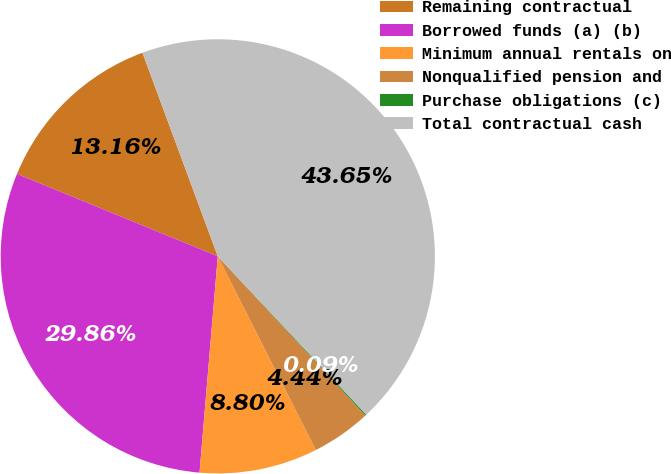<chart> <loc_0><loc_0><loc_500><loc_500><pie_chart><fcel>Remaining contractual<fcel>Borrowed funds (a) (b)<fcel>Minimum annual rentals on<fcel>Nonqualified pension and<fcel>Purchase obligations (c)<fcel>Total contractual cash<nl><fcel>13.16%<fcel>29.86%<fcel>8.8%<fcel>4.44%<fcel>0.09%<fcel>43.65%<nl></chart> 